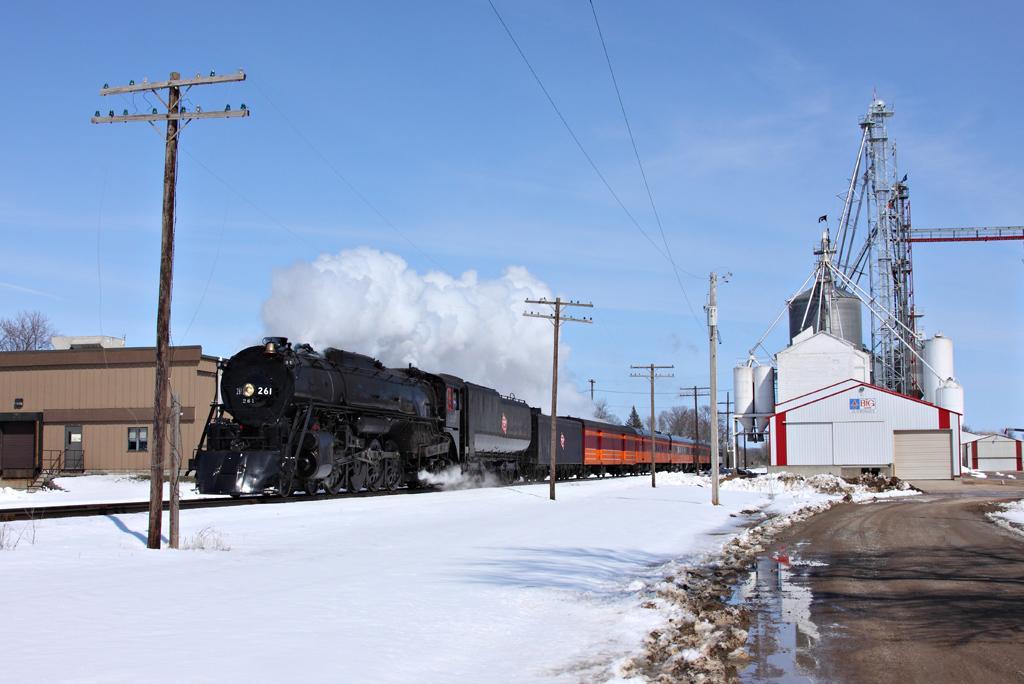Describe this image in one or two sentences. In the picture we can see a railway station with snow surface and poles on it with wires and beside it, we can see the train and in the background we can see the sky with clouds. 